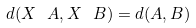Convert formula to latex. <formula><loc_0><loc_0><loc_500><loc_500>d ( X \ A , X \ B ) = d ( A , B )</formula> 